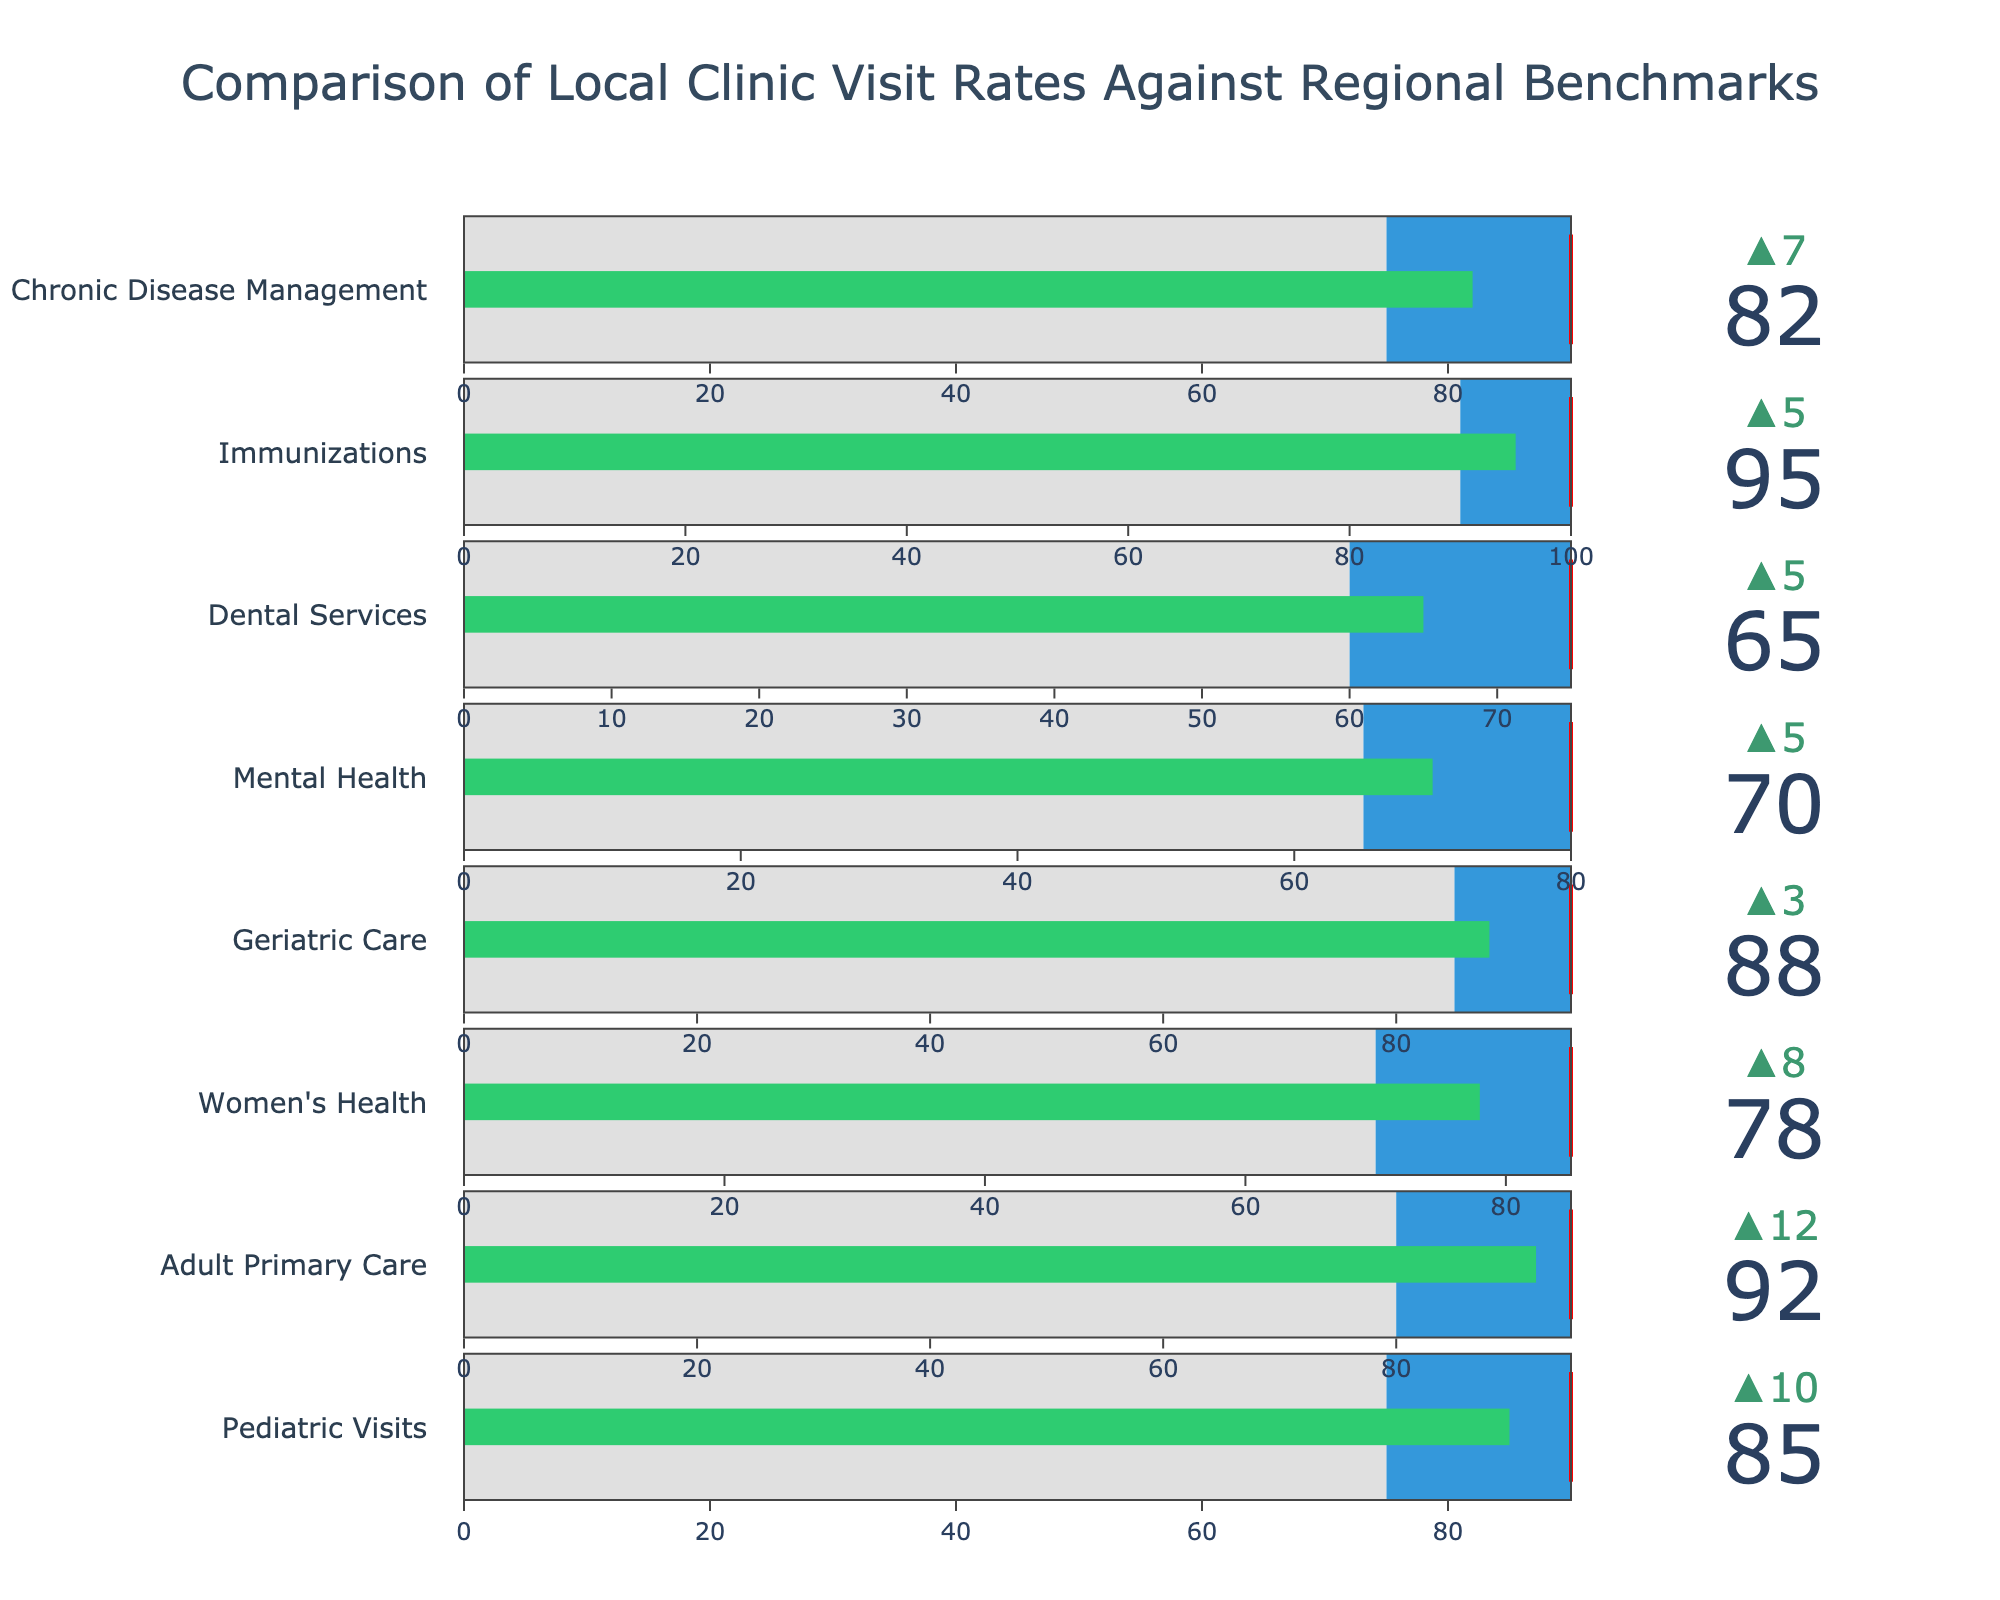what is the title of the figure? The title of the figure is displayed prominently at the top.
Answer: Comparison of Local Clinic Visit Rates Against Regional Benchmarks How many categories are shown in the figure? By counting the number of distinct category titles in the bullet chart, we can determine the number of categories.
Answer: 8 Which category has the highest actual visit rate? By inspecting the 'Actual' values across all categories in the chart, we can identify the one with the highest value.
Answer: Immunizations What is the difference between the Actual and Comparative values for Pediatric Visits? Subtract the Comparative value from the Actual value for the Pediatric Visits category.
Answer: 10 Which category has the smallest gap between Actual and Target values? To find the smallest gap, we subtract each category's Actual value from its Target value and identify the smallest result.
Answer: Adult Primary Care Is the actual value for Dental Services greater or lesser than the Comparative value? Compare the Actual value with the Comparative value for the Dental Services category.
Answer: Greater For Geriatric Care, how close is the actual value to the target value in terms of percentage of the target? Divide the Actual value by the Target value for Geriatric Care and multiply by 100 to get the percentage.
Answer: 92.63% Which categories' actual values exceed their comparative values by more than 10 units? Subtract the Comparative from the Actual values for each category to find those that exceed by more than 10 units.
Answer: Pediatric Visits, Adult Primary Care, Mental Health Do any categories have an actual value equal to the comparative value? Check if any category has the same Actual and Comparative values.
Answer: No What color is used to indicate the actual value's bar within the bullet chart? The color used for the actual value's bar within the visual representation.
Answer: Green 